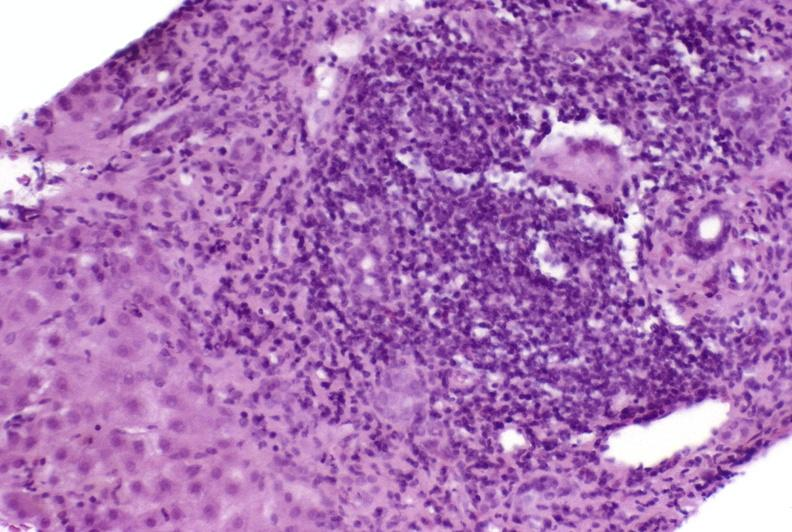what is present?
Answer the question using a single word or phrase. Liver 